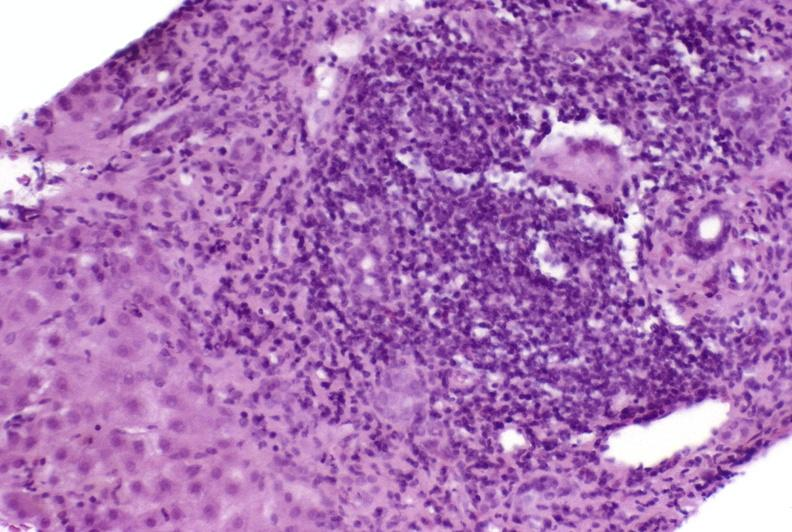what is present?
Answer the question using a single word or phrase. Liver 